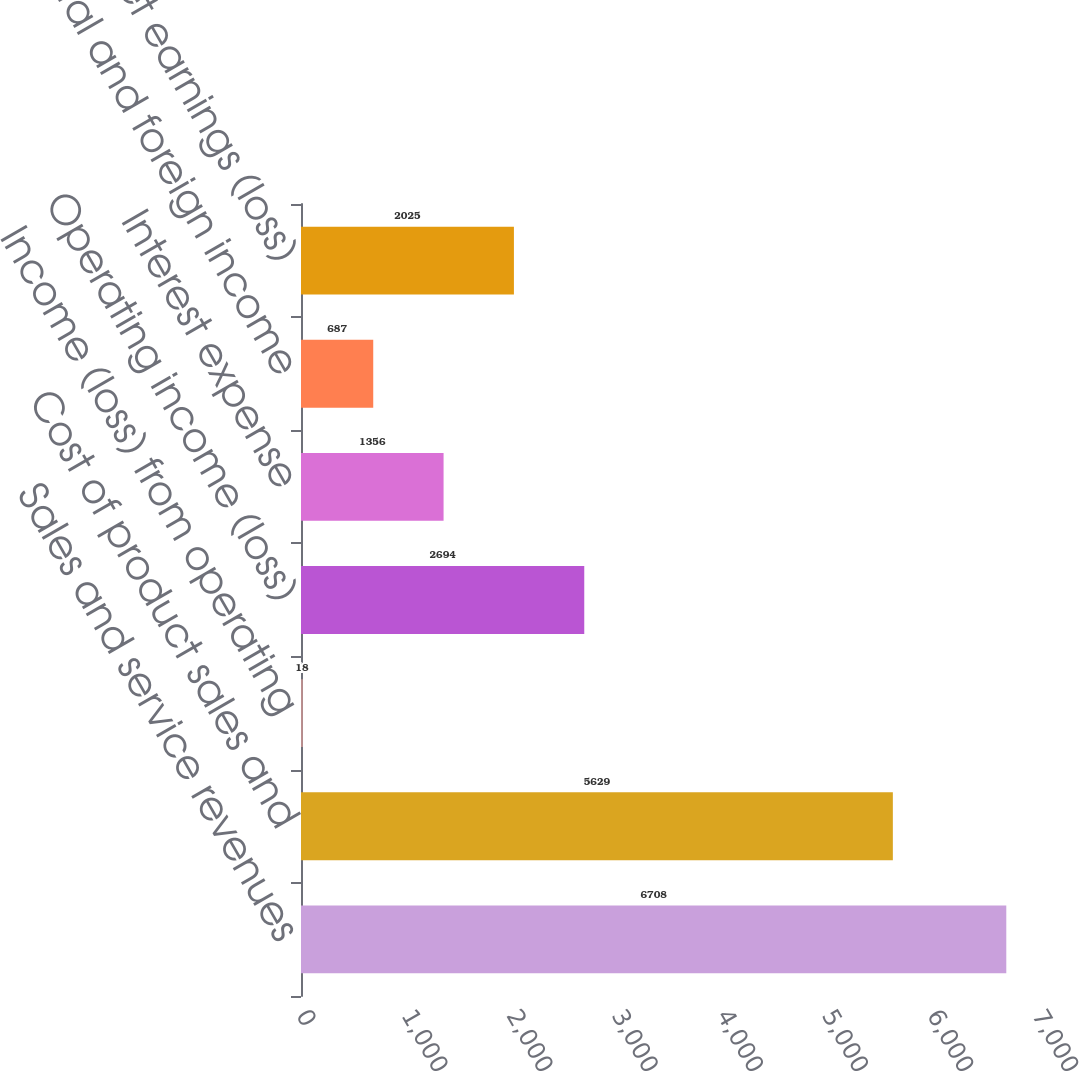Convert chart. <chart><loc_0><loc_0><loc_500><loc_500><bar_chart><fcel>Sales and service revenues<fcel>Cost of product sales and<fcel>Income (loss) from operating<fcel>Operating income (loss)<fcel>Interest expense<fcel>Federal and foreign income<fcel>Net earnings (loss)<nl><fcel>6708<fcel>5629<fcel>18<fcel>2694<fcel>1356<fcel>687<fcel>2025<nl></chart> 